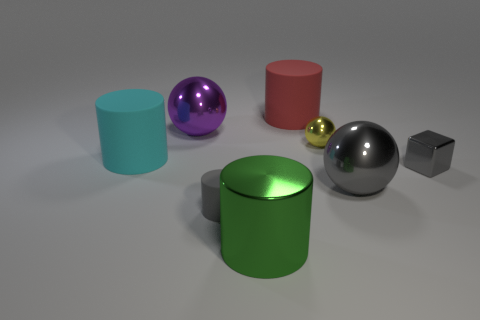There is a big shiny thing on the left side of the big shiny cylinder; how many things are in front of it? In the image, there is a large green cylinder on the left, and directly in front of it, there are two objects: a smaller red cylinder and a gold sphere. 